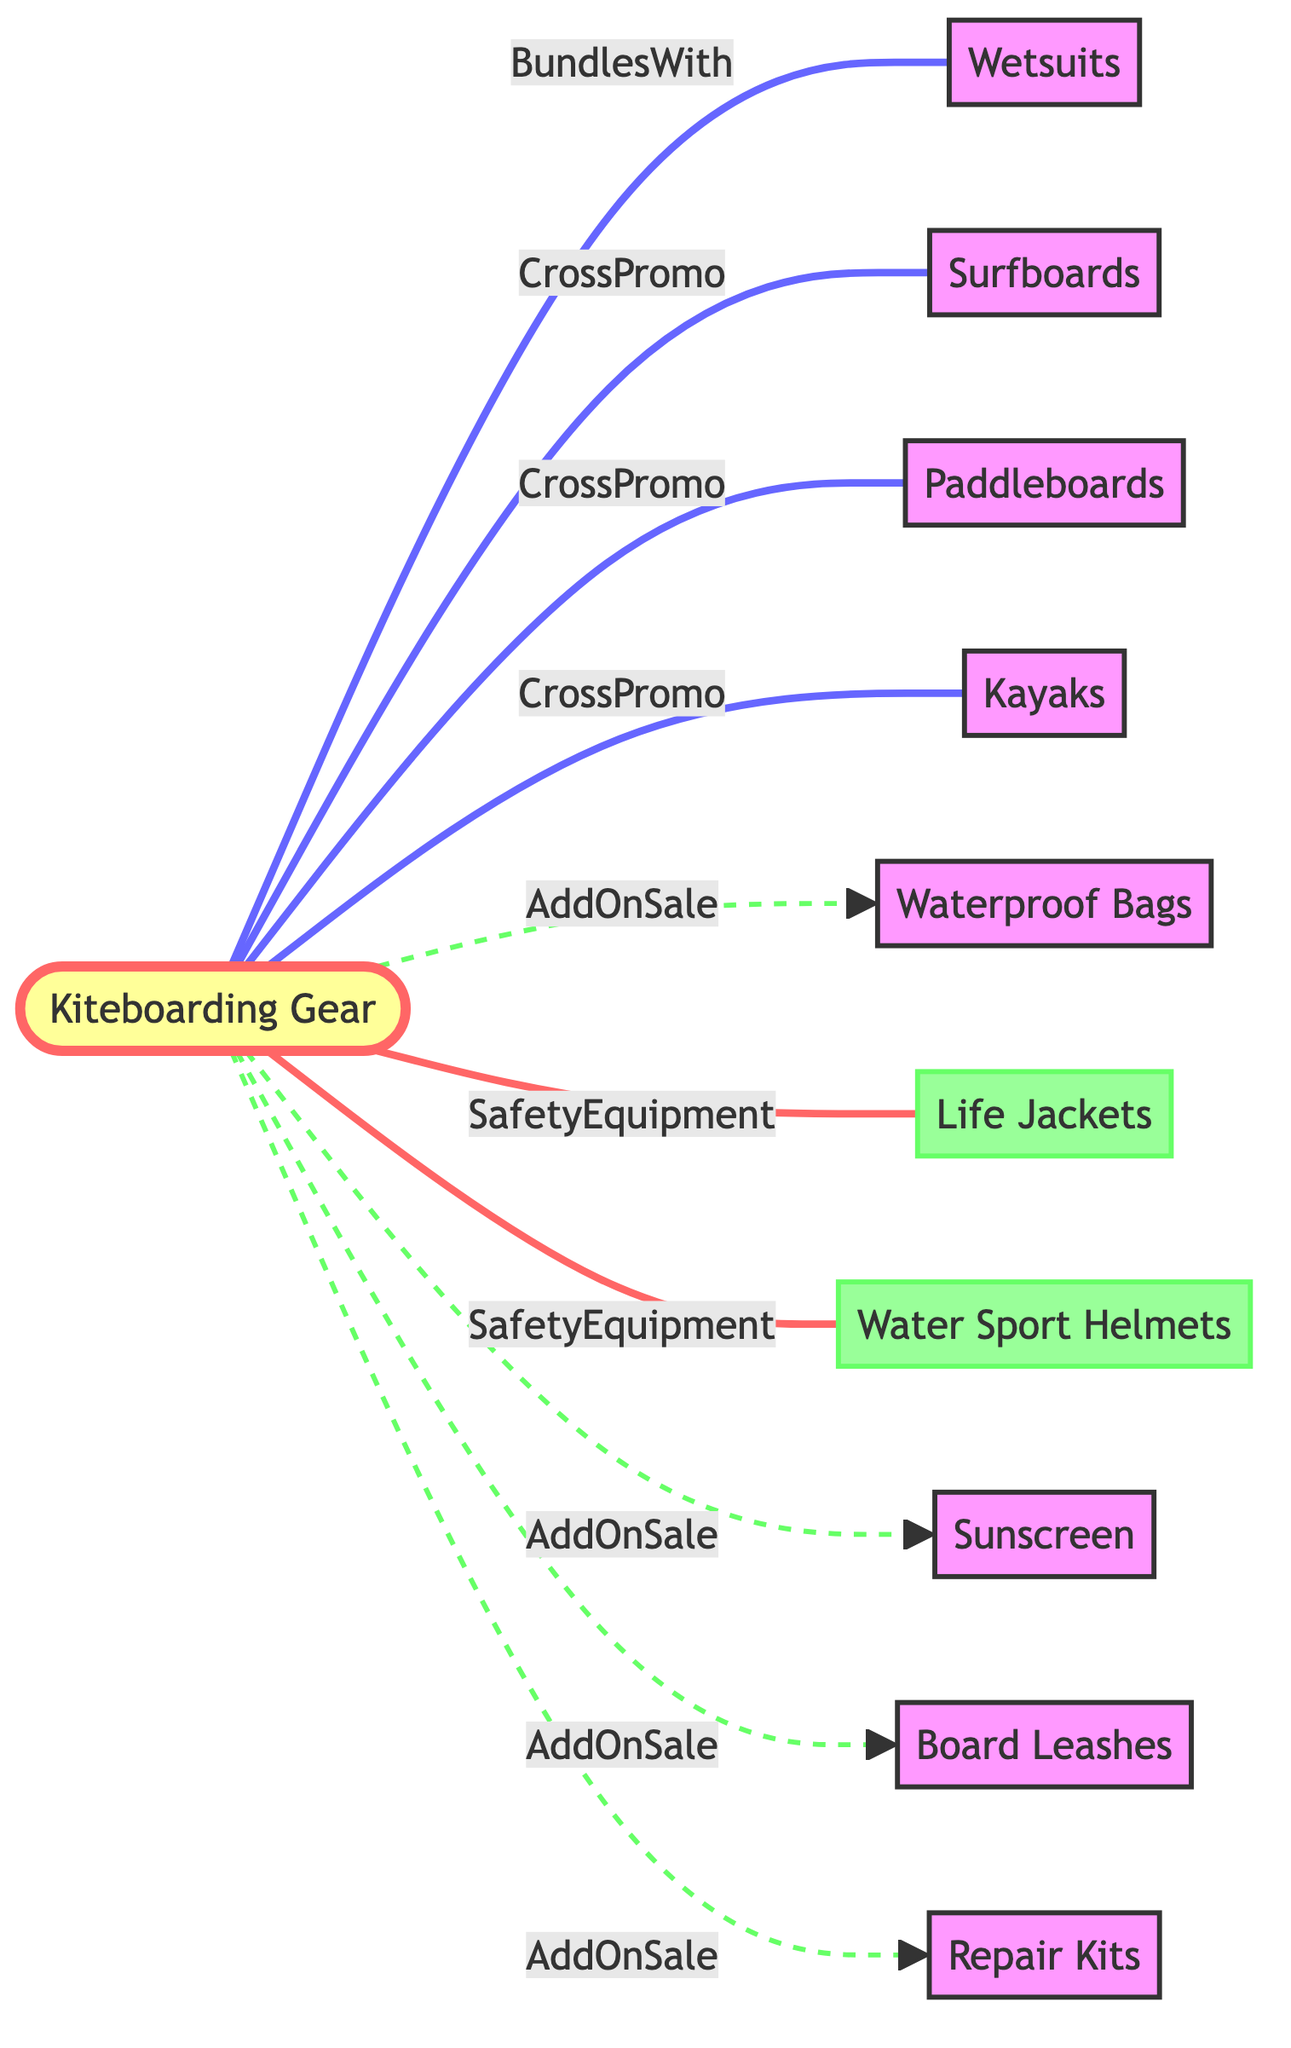What is the total number of nodes in the diagram? The diagram lists various entities that are part of the cross-promotion network. By counting all the unique nodes, we find 11 nodes present.
Answer: 11 How many cross-promotion relationships are shown in the diagram? By reviewing the edges, we identify the relationships that are labeled as "CrossPromo". There are 4 such relationships linking kiteboarding gear to surfboards, paddleboards, and kayaks.
Answer: 4 Which product is bundled with kiteboarding gear? According to the edges, the only relationship labeled "BundlesWith" connects kiteboarding gear to wetsuits, indicating this product is bundled.
Answer: Wetsuits What type of relationship connects kiteboarding gear and life jackets? The edge linking kiteboarding gear to life jackets is labeled "SafetyEquipment", indicating the nature of this relationship.
Answer: SafetyEquipment List all products that have an "AddOnSale" relationship with kiteboarding gear. Checking the edges for the "AddOnSale" labels, we see the products connected are waterproof bags, sunscreen, board leashes, and repair kits.
Answer: Waterproof Bags, Sunscreen, Board Leashes, Repair Kits Which two products have a "CrossPromo" relationship with kiteboarding gear? Among the edges, there are several "CrossPromo" links; picking any two would include surfboards and paddleboards, as both are connected through this type of relationship to kiteboarding gear.
Answer: Surfboards, Paddleboards What visual style distinguishes safety equipment in the diagram? The diagram uses a specific class definition to define a unique fill and stroke style for safety equipment, which is represented by a light green fill and a darker green stroke, making it visually distinct.
Answer: Light green fill How many types of relationships are depicted in the diagram? By examining the relationships labeled on the edges, we identify three unique types: "BundlesWith", "CrossPromo", and "AddOnSale", and also "SafetyEquipment", leading to a total of four types being present.
Answer: 4 Which product is explicitly stated to be an add-on sale with kiteboarding gear? The edge labeled "AddOnSale" with kiteboarding gear can refer to multiple products, specifically highlighting waterproof bags, offering clarity in what can be bundled as add-ons in the sales approach.
Answer: Waterproof Bags 